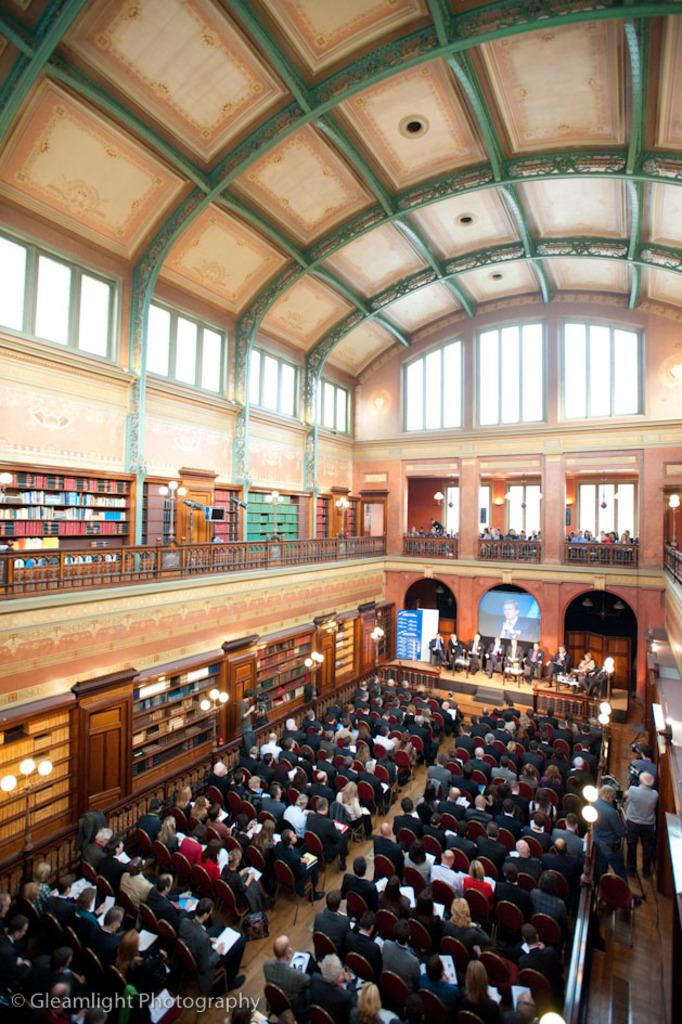What type of location is depicted in the image? The image is an inside view of a building. What are the people in the image doing? There are people sitting on chairs in the image. What can be seen on the racks in the image? There are books on the racks in the image. What is the purpose of the screen in the image? The purpose of the screen in the image is not specified, but it could be used for displaying information or presentations. What type of lighting is present in the image? There are lights in the image, which provide illumination. Can you hear the whistle of the airplane in the image? There is no airplane or whistle present in the image; it is an inside view of a building with people sitting on chairs, racks with books, a screen, and lights. 